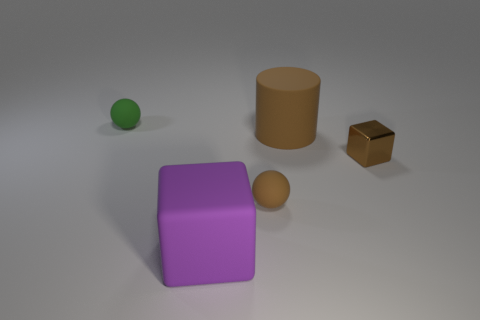Add 4 large green blocks. How many objects exist? 9 Subtract all spheres. How many objects are left? 3 Subtract 0 blue balls. How many objects are left? 5 Subtract all shiny objects. Subtract all large purple cubes. How many objects are left? 3 Add 1 tiny green rubber things. How many tiny green rubber things are left? 2 Add 1 large metallic cubes. How many large metallic cubes exist? 1 